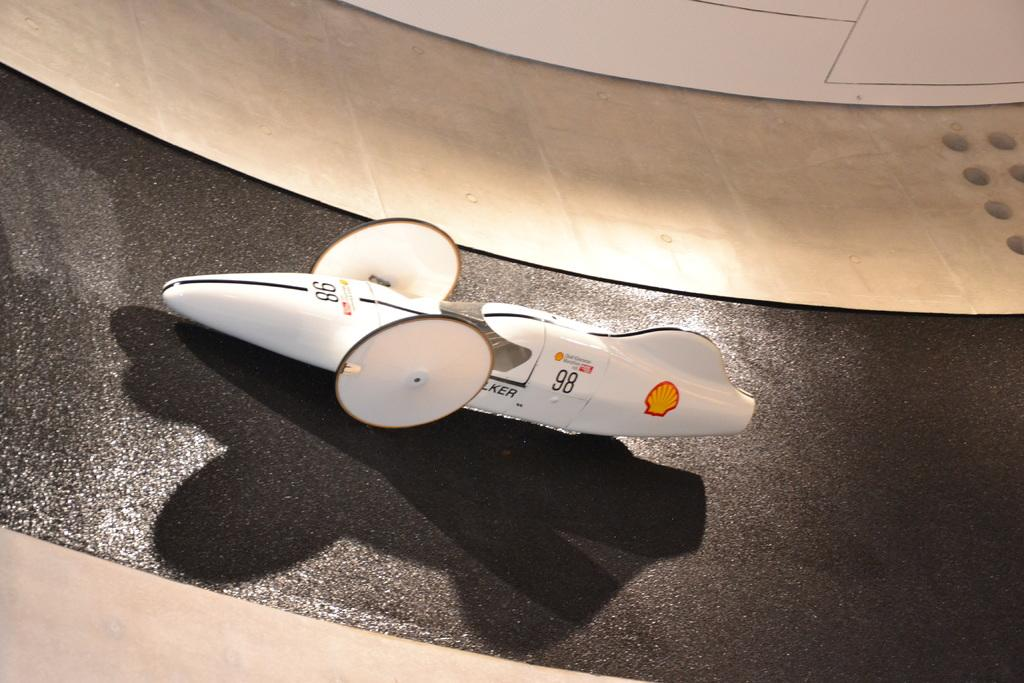What type of toy is present in the image? There is a toy car in the image. What color is the surface at the bottom of the image? The surface at the bottom of the image is black. How many monkeys are sitting on the toy car in the image? There are no monkeys present in the image; it only features a toy car. What type of cherry is visible on the black surface in the image? There is no cherry present in the image; the black surface is not associated with any fruit. 